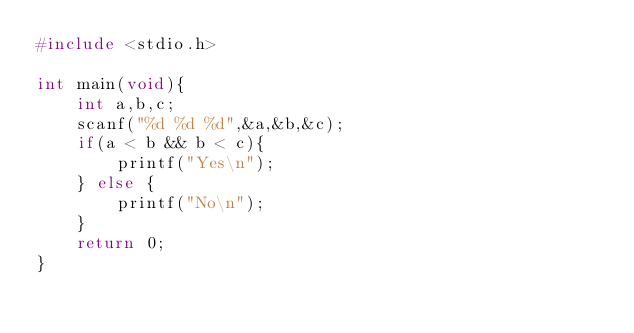Convert code to text. <code><loc_0><loc_0><loc_500><loc_500><_C_>#include <stdio.h>

int main(void){
    int a,b,c;
    scanf("%d %d %d",&a,&b,&c);
    if(a < b && b < c){
        printf("Yes\n");
    } else {
        printf("No\n");
    }
    return 0;
}</code> 